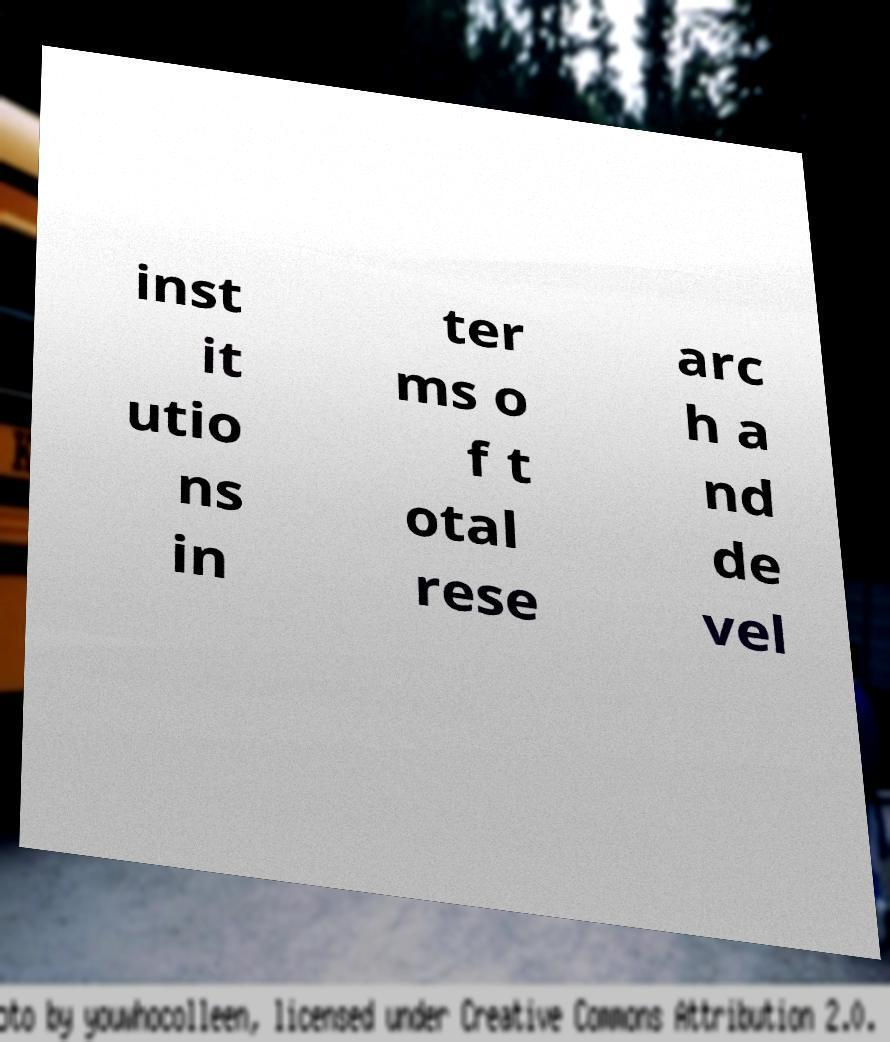Could you assist in decoding the text presented in this image and type it out clearly? inst it utio ns in ter ms o f t otal rese arc h a nd de vel 